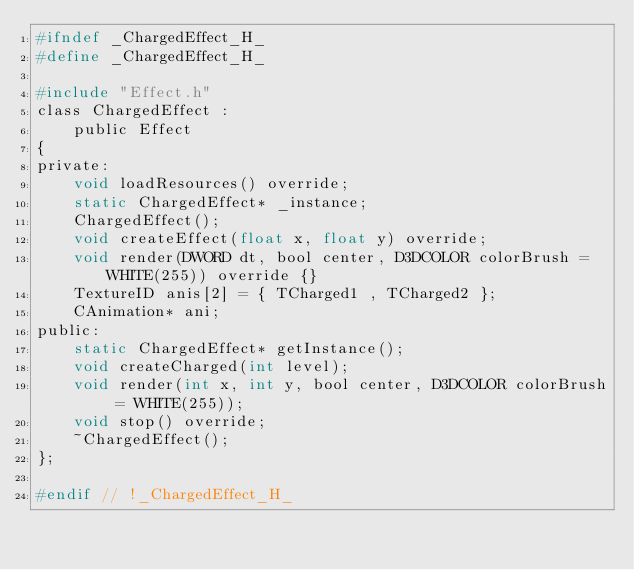<code> <loc_0><loc_0><loc_500><loc_500><_C_>#ifndef _ChargedEffect_H_
#define _ChargedEffect_H_

#include "Effect.h"
class ChargedEffect :
	public Effect
{
private:
	void loadResources() override;
	static ChargedEffect* _instance;
	ChargedEffect();
	void createEffect(float x, float y) override;
	void render(DWORD dt, bool center, D3DCOLOR colorBrush = WHITE(255)) override {}
	TextureID anis[2] = { TCharged1 , TCharged2 };
	CAnimation* ani;
public:
	static ChargedEffect* getInstance();
	void createCharged(int level);
	void render(int x, int y, bool center, D3DCOLOR colorBrush = WHITE(255));
	void stop() override;
	~ChargedEffect();
};

#endif // !_ChargedEffect_H_</code> 